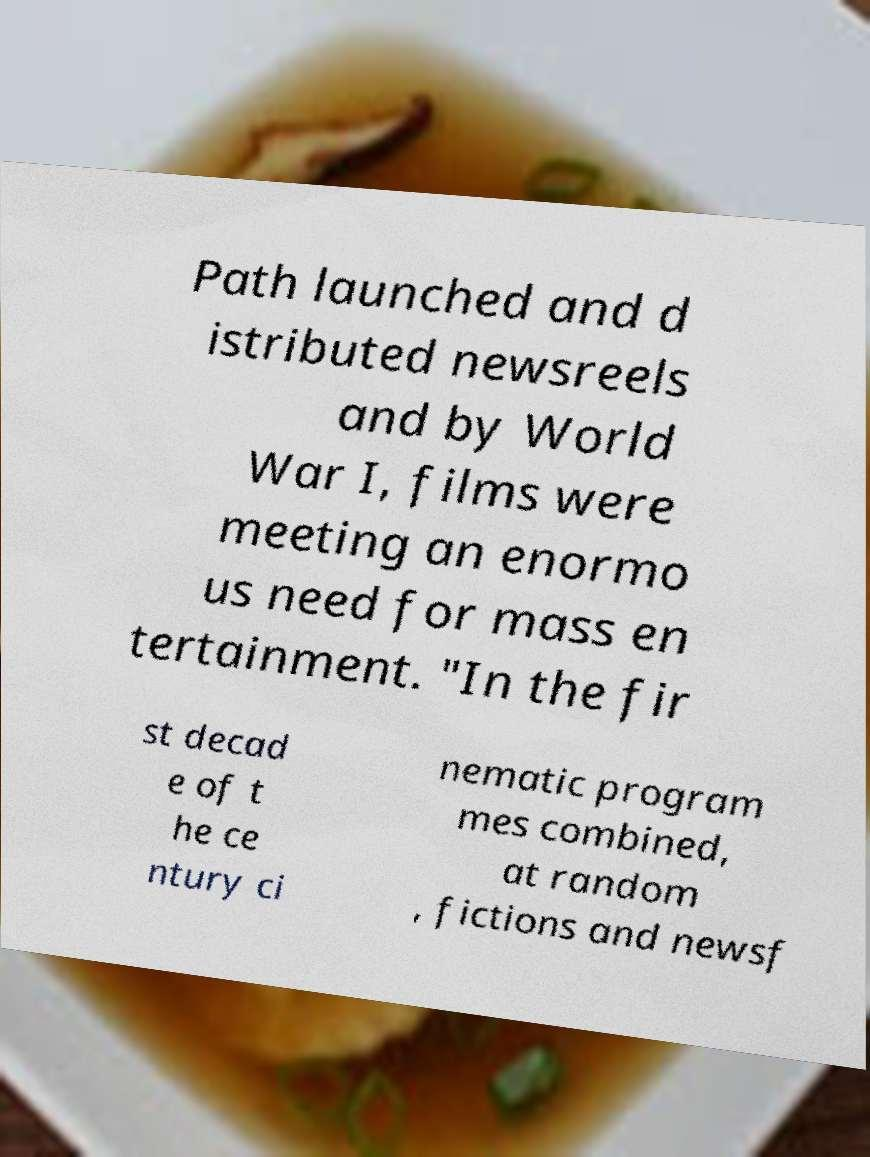I need the written content from this picture converted into text. Can you do that? Path launched and d istributed newsreels and by World War I, films were meeting an enormo us need for mass en tertainment. "In the fir st decad e of t he ce ntury ci nematic program mes combined, at random , fictions and newsf 